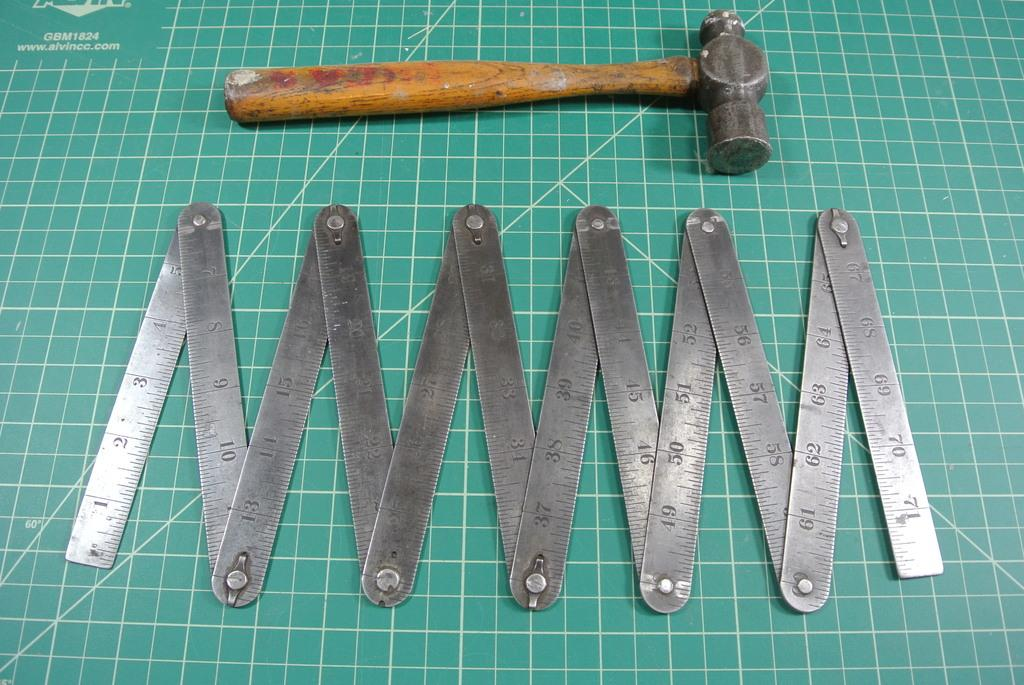<image>
Give a short and clear explanation of the subsequent image. Giant hammer and ruler on a green surface that says GBM2814. 